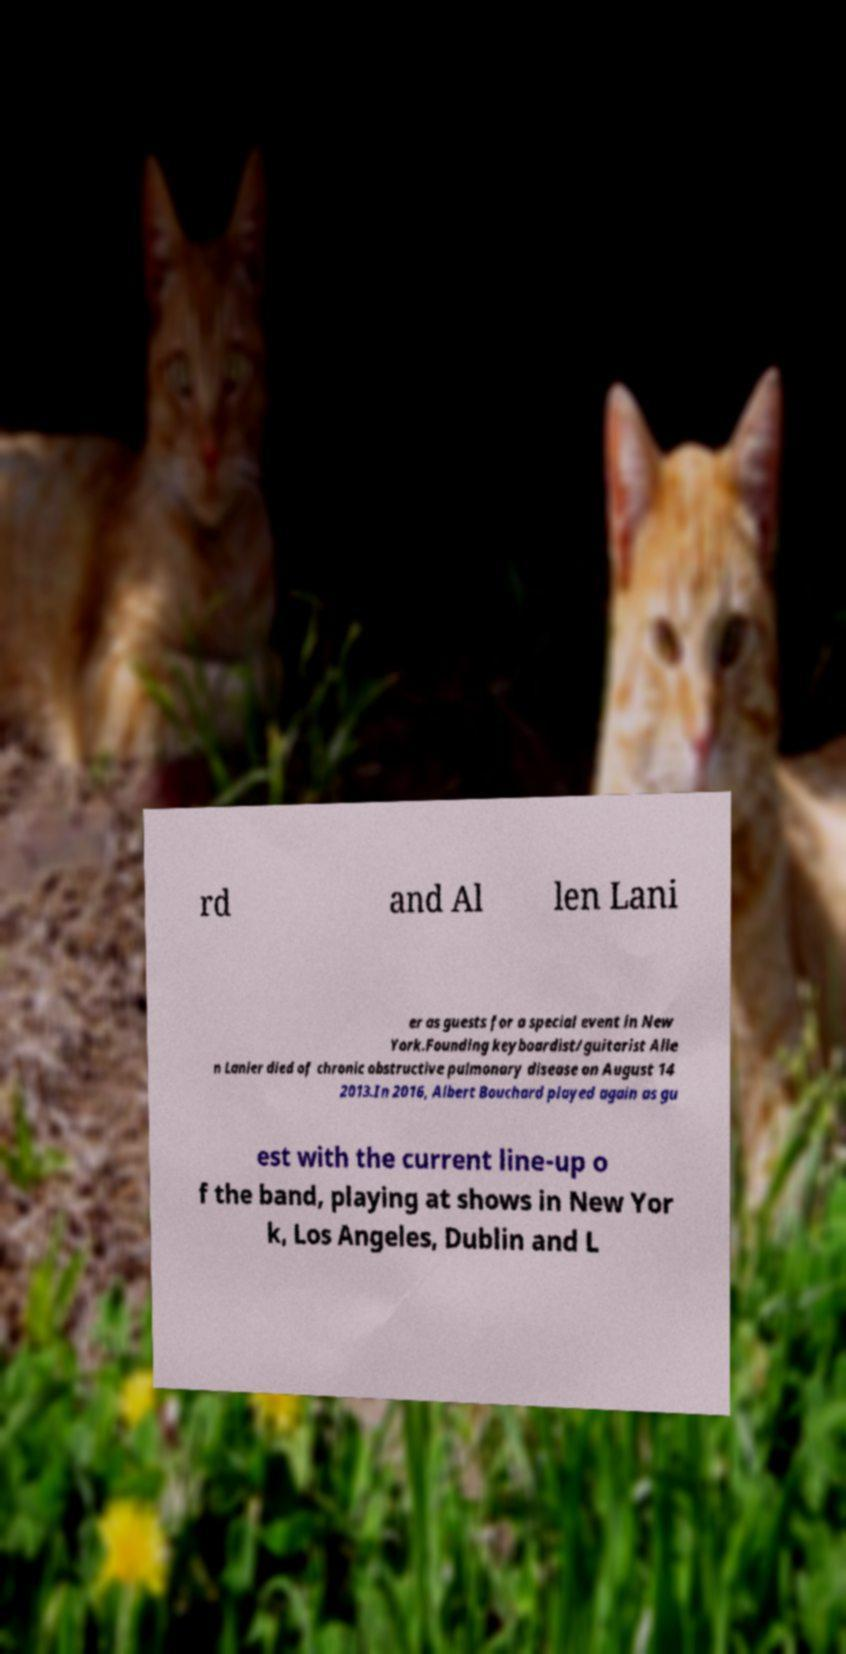Could you extract and type out the text from this image? rd and Al len Lani er as guests for a special event in New York.Founding keyboardist/guitarist Alle n Lanier died of chronic obstructive pulmonary disease on August 14 2013.In 2016, Albert Bouchard played again as gu est with the current line-up o f the band, playing at shows in New Yor k, Los Angeles, Dublin and L 